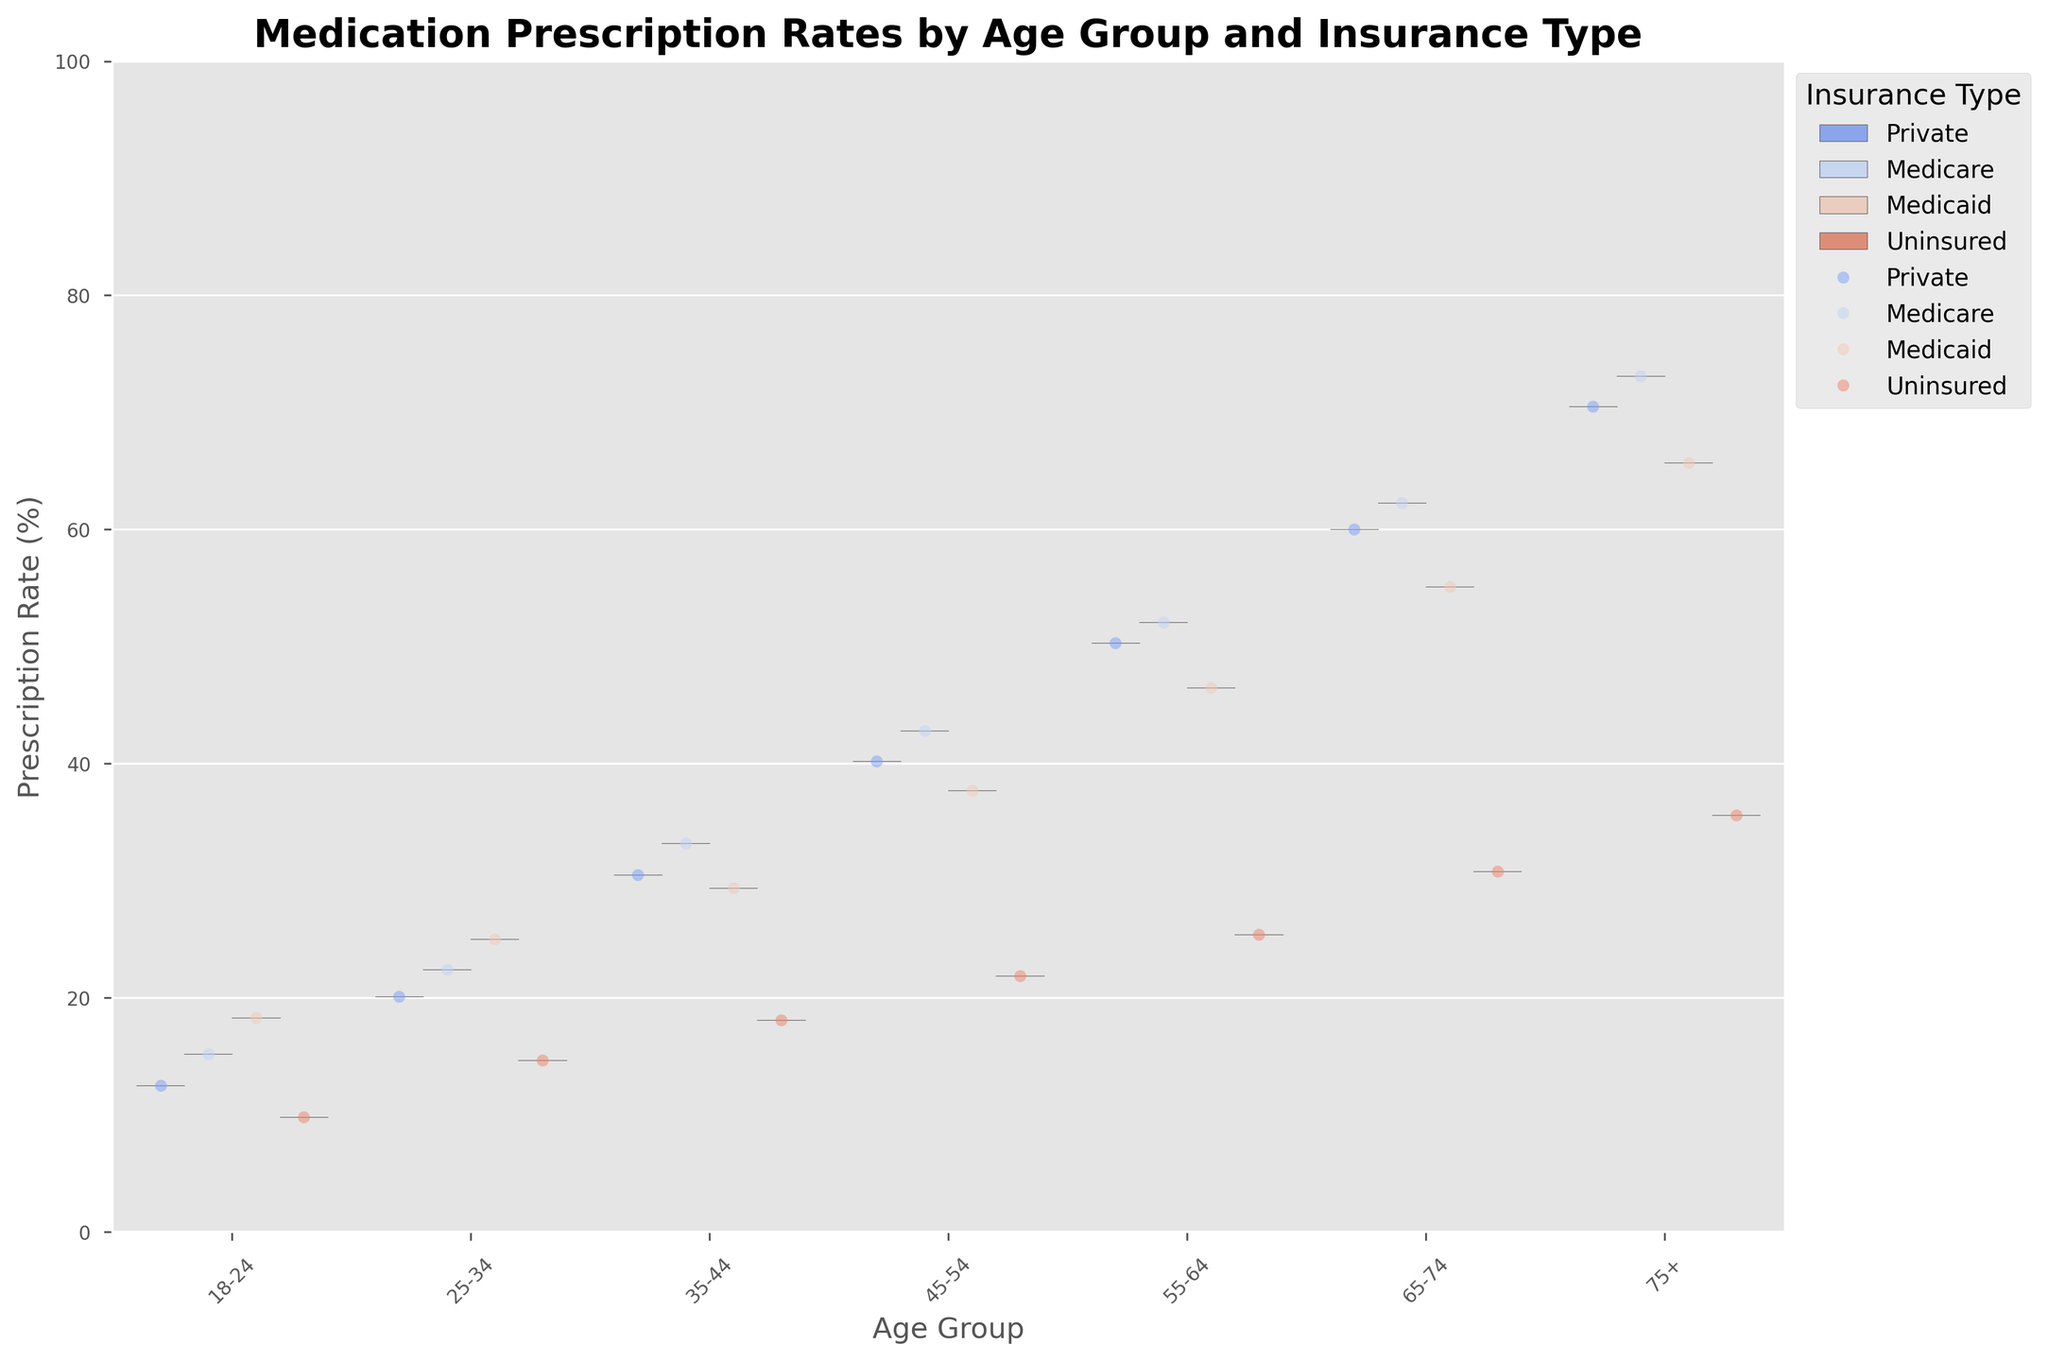What is the title of the figure? Look at the top of the figure where the title is usually displayed.
Answer: Medication Prescription Rates by Age Group and Insurance Type What are the labels of the x and y axes? Examine the text along the horizontal and vertical axes.
Answer: Age Group and Prescription Rate (%) Which age group has the highest prescription rate for Medicare? Locate the point corresponding to the highest value in the Medicare data series and identify the associated age group.
Answer: 75+ How many insurance types are compared in the violin plot? Count the distinct colors or legend categories corresponding to different insurance types.
Answer: 4 Which insurance type generally shows the lowest prescription rates across all age groups? Observe the position and density of the data points for each insurance type across all age groups.
Answer: Uninsured What is the prescription rate range for the 35-44 age group with Medicaid insurance? Identify the limits of the violin plot for Medicaid insurance within the 35-44 age group. Estimate minimum and maximum bounds.
Answer: About 29.4 to 33.2% Which age group shows the greatest variability in prescription rates for Private insurance? Look at the width and extent of the violin plot for Private insurance in each age group to identify the one with the broadest spread.
Answer: 75+ Compare the average prescription rates for Private and Medicaid insurance within the 55-64 age group. Calculate/estimate the central tendency (median/mean) for both Private and Medicaid insurance within the 55-64 age bracket from the violin plot or jittered points.
Answer: Private (~50.3%) vs. Medicaid (~46.5%) Is there a consistent trend in prescription rates as age increases across different insurance types? Examine the general slope or direction of the data points for each insurance type as age groups progress from youngest to oldest.
Answer: Yes, rates generally increase with age What can we infer about the prescription rates for the Uninsured group? Look at the density and position of points in the violin plots for the Uninsured category within each age group to draw a conclusion.
Answer: Generally lower than other insurance types 